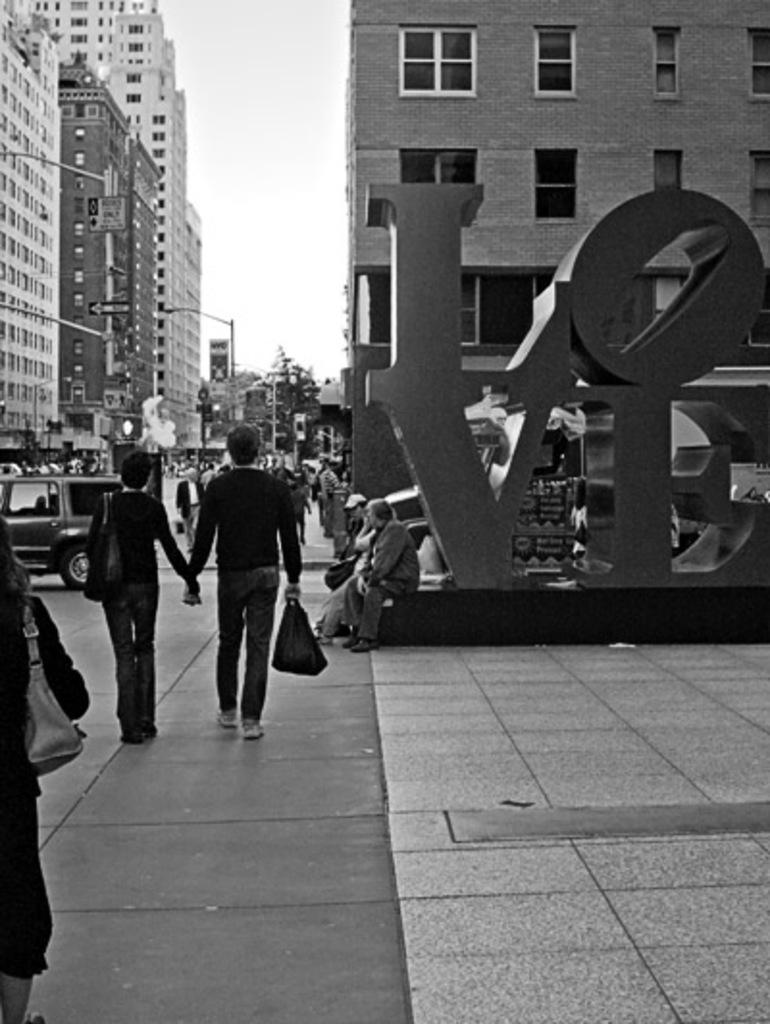What is the color scheme of the image? The image is black and white. What types of structures can be seen in the image? There are buildings and sculptures in the image. What is happening on the road in the image? There are people on the road in the image. What types of transportation are visible in the image? Motor vehicles are visible in the image. What other objects can be seen on the road? Street poles are present in the image. What is used to illuminate the road at night? Street lights are visible in the image. What type of natural elements are present in the image? Trees are present in the image. What part of the environment is visible in the image? The sky is visible in the image. What type of mint is growing on the street poles in the image? There is no mint growing on the street poles in the image. What emotion can be seen on the nose of the person in the image? There is no emotion depicted on a nose in the image, as noses are not capable of expressing emotions. 